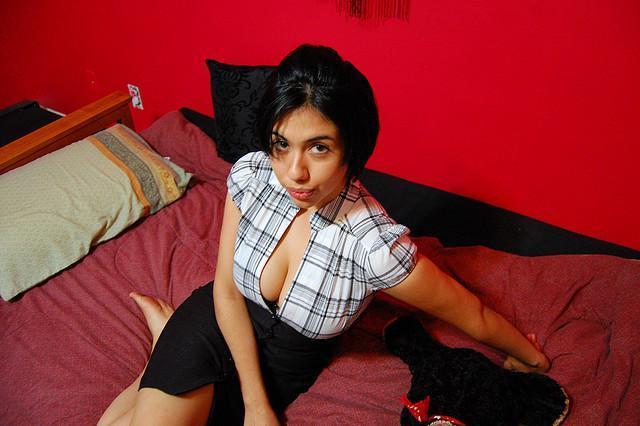How many doors are on the train car?
Give a very brief answer. 0. 